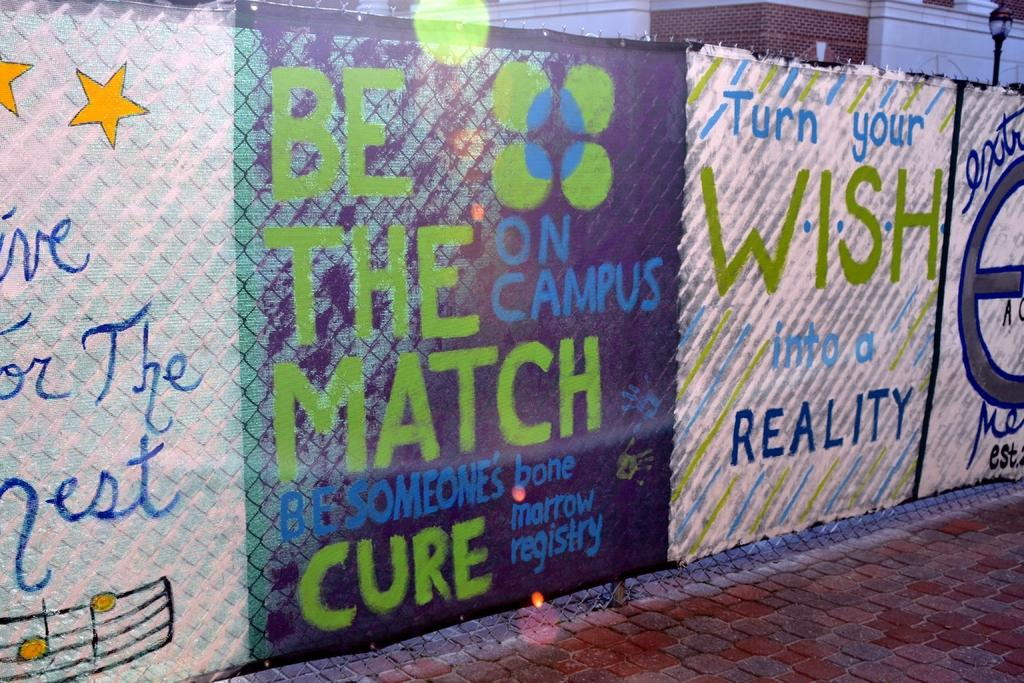<image>
Summarize the visual content of the image. words on a fence that say to turn your wish into reality 